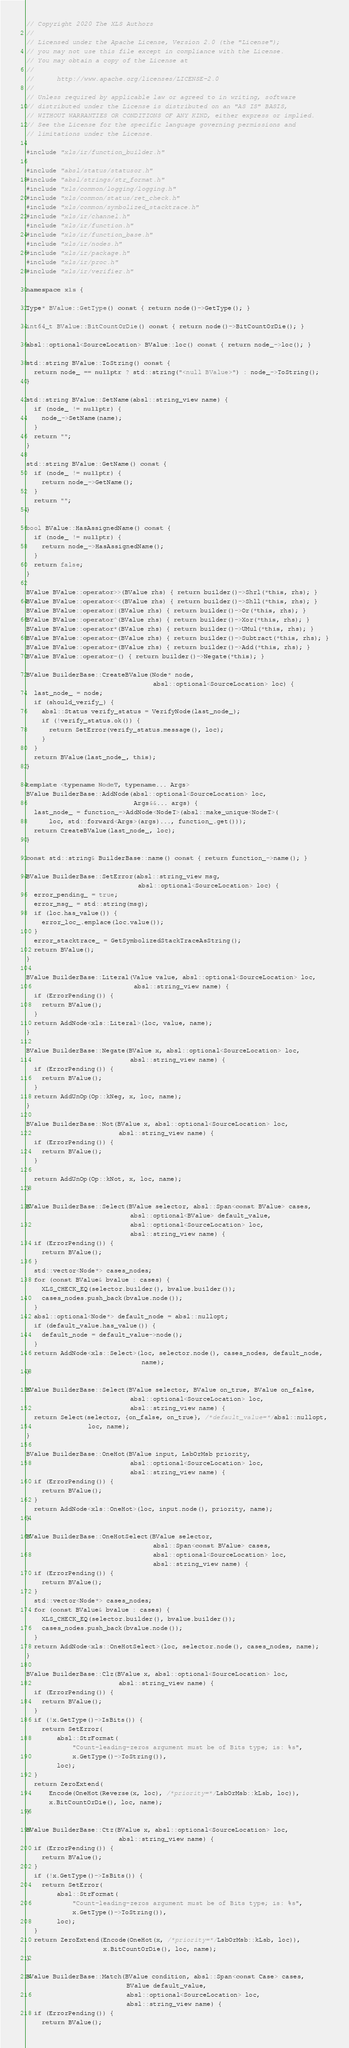<code> <loc_0><loc_0><loc_500><loc_500><_C++_>// Copyright 2020 The XLS Authors
//
// Licensed under the Apache License, Version 2.0 (the "License");
// you may not use this file except in compliance with the License.
// You may obtain a copy of the License at
//
//      http://www.apache.org/licenses/LICENSE-2.0
//
// Unless required by applicable law or agreed to in writing, software
// distributed under the License is distributed on an "AS IS" BASIS,
// WITHOUT WARRANTIES OR CONDITIONS OF ANY KIND, either express or implied.
// See the License for the specific language governing permissions and
// limitations under the License.

#include "xls/ir/function_builder.h"

#include "absl/status/statusor.h"
#include "absl/strings/str_format.h"
#include "xls/common/logging/logging.h"
#include "xls/common/status/ret_check.h"
#include "xls/common/symbolized_stacktrace.h"
#include "xls/ir/channel.h"
#include "xls/ir/function.h"
#include "xls/ir/function_base.h"
#include "xls/ir/nodes.h"
#include "xls/ir/package.h"
#include "xls/ir/proc.h"
#include "xls/ir/verifier.h"

namespace xls {

Type* BValue::GetType() const { return node()->GetType(); }

int64_t BValue::BitCountOrDie() const { return node()->BitCountOrDie(); }

absl::optional<SourceLocation> BValue::loc() const { return node_->loc(); }

std::string BValue::ToString() const {
  return node_ == nullptr ? std::string("<null BValue>") : node_->ToString();
}

std::string BValue::SetName(absl::string_view name) {
  if (node_ != nullptr) {
    node_->SetName(name);
  }
  return "";
}

std::string BValue::GetName() const {
  if (node_ != nullptr) {
    return node_->GetName();
  }
  return "";
}

bool BValue::HasAssignedName() const {
  if (node_ != nullptr) {
    return node_->HasAssignedName();
  }
  return false;
}

BValue BValue::operator>>(BValue rhs) { return builder()->Shrl(*this, rhs); }
BValue BValue::operator<<(BValue rhs) { return builder()->Shll(*this, rhs); }
BValue BValue::operator|(BValue rhs) { return builder()->Or(*this, rhs); }
BValue BValue::operator^(BValue rhs) { return builder()->Xor(*this, rhs); }
BValue BValue::operator*(BValue rhs) { return builder()->UMul(*this, rhs); }
BValue BValue::operator-(BValue rhs) { return builder()->Subtract(*this, rhs); }
BValue BValue::operator+(BValue rhs) { return builder()->Add(*this, rhs); }
BValue BValue::operator-() { return builder()->Negate(*this); }

BValue BuilderBase::CreateBValue(Node* node,
                                 absl::optional<SourceLocation> loc) {
  last_node_ = node;
  if (should_verify_) {
    absl::Status verify_status = VerifyNode(last_node_);
    if (!verify_status.ok()) {
      return SetError(verify_status.message(), loc);
    }
  }
  return BValue(last_node_, this);
}

template <typename NodeT, typename... Args>
BValue BuilderBase::AddNode(absl::optional<SourceLocation> loc,
                            Args&&... args) {
  last_node_ = function_->AddNode<NodeT>(absl::make_unique<NodeT>(
      loc, std::forward<Args>(args)..., function_.get()));
  return CreateBValue(last_node_, loc);
}

const std::string& BuilderBase::name() const { return function_->name(); }

BValue BuilderBase::SetError(absl::string_view msg,
                             absl::optional<SourceLocation> loc) {
  error_pending_ = true;
  error_msg_ = std::string(msg);
  if (loc.has_value()) {
    error_loc_.emplace(loc.value());
  }
  error_stacktrace_ = GetSymbolizedStackTraceAsString();
  return BValue();
}

BValue BuilderBase::Literal(Value value, absl::optional<SourceLocation> loc,
                            absl::string_view name) {
  if (ErrorPending()) {
    return BValue();
  }
  return AddNode<xls::Literal>(loc, value, name);
}

BValue BuilderBase::Negate(BValue x, absl::optional<SourceLocation> loc,
                           absl::string_view name) {
  if (ErrorPending()) {
    return BValue();
  }
  return AddUnOp(Op::kNeg, x, loc, name);
}

BValue BuilderBase::Not(BValue x, absl::optional<SourceLocation> loc,
                        absl::string_view name) {
  if (ErrorPending()) {
    return BValue();
  }

  return AddUnOp(Op::kNot, x, loc, name);
}

BValue BuilderBase::Select(BValue selector, absl::Span<const BValue> cases,
                           absl::optional<BValue> default_value,
                           absl::optional<SourceLocation> loc,
                           absl::string_view name) {
  if (ErrorPending()) {
    return BValue();
  }
  std::vector<Node*> cases_nodes;
  for (const BValue& bvalue : cases) {
    XLS_CHECK_EQ(selector.builder(), bvalue.builder());
    cases_nodes.push_back(bvalue.node());
  }
  absl::optional<Node*> default_node = absl::nullopt;
  if (default_value.has_value()) {
    default_node = default_value->node();
  }
  return AddNode<xls::Select>(loc, selector.node(), cases_nodes, default_node,
                              name);
}

BValue BuilderBase::Select(BValue selector, BValue on_true, BValue on_false,
                           absl::optional<SourceLocation> loc,
                           absl::string_view name) {
  return Select(selector, {on_false, on_true}, /*default_value=*/absl::nullopt,
                loc, name);
}

BValue BuilderBase::OneHot(BValue input, LsbOrMsb priority,
                           absl::optional<SourceLocation> loc,
                           absl::string_view name) {
  if (ErrorPending()) {
    return BValue();
  }
  return AddNode<xls::OneHot>(loc, input.node(), priority, name);
}

BValue BuilderBase::OneHotSelect(BValue selector,
                                 absl::Span<const BValue> cases,
                                 absl::optional<SourceLocation> loc,
                                 absl::string_view name) {
  if (ErrorPending()) {
    return BValue();
  }
  std::vector<Node*> cases_nodes;
  for (const BValue& bvalue : cases) {
    XLS_CHECK_EQ(selector.builder(), bvalue.builder());
    cases_nodes.push_back(bvalue.node());
  }
  return AddNode<xls::OneHotSelect>(loc, selector.node(), cases_nodes, name);
}

BValue BuilderBase::Clz(BValue x, absl::optional<SourceLocation> loc,
                        absl::string_view name) {
  if (ErrorPending()) {
    return BValue();
  }
  if (!x.GetType()->IsBits()) {
    return SetError(
        absl::StrFormat(
            "Count-leading-zeros argument must be of Bits type; is: %s",
            x.GetType()->ToString()),
        loc);
  }
  return ZeroExtend(
      Encode(OneHot(Reverse(x, loc), /*priority=*/LsbOrMsb::kLsb, loc)),
      x.BitCountOrDie(), loc, name);
}

BValue BuilderBase::Ctz(BValue x, absl::optional<SourceLocation> loc,
                        absl::string_view name) {
  if (ErrorPending()) {
    return BValue();
  }
  if (!x.GetType()->IsBits()) {
    return SetError(
        absl::StrFormat(
            "Count-leading-zeros argument must be of Bits type; is: %s",
            x.GetType()->ToString()),
        loc);
  }
  return ZeroExtend(Encode(OneHot(x, /*priority=*/LsbOrMsb::kLsb, loc)),
                    x.BitCountOrDie(), loc, name);
}

BValue BuilderBase::Match(BValue condition, absl::Span<const Case> cases,
                          BValue default_value,
                          absl::optional<SourceLocation> loc,
                          absl::string_view name) {
  if (ErrorPending()) {
    return BValue();</code> 